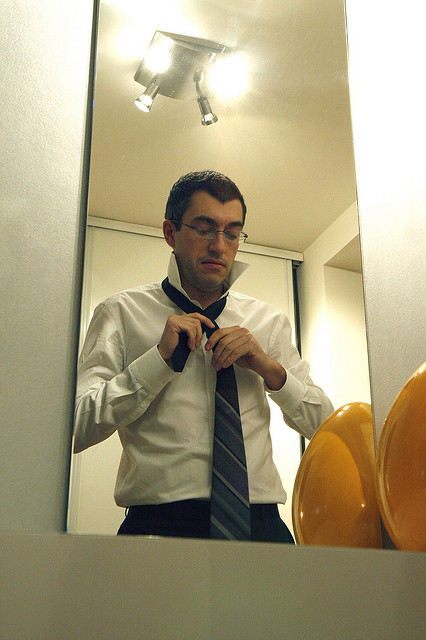What might the man be preparing for given his actions and attire? Given the man's actions of adjusting his necktie and wearing a formal white shirt, it is likely he is preparing for a formal event, such as a business meeting, interview, or social occasion. The image captures a moment of personal preparation, emphasizing his attention to detail and desire to present himself well. 